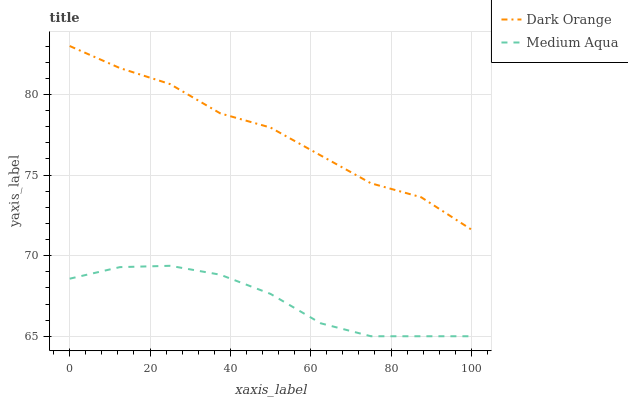Does Medium Aqua have the minimum area under the curve?
Answer yes or no. Yes. Does Dark Orange have the maximum area under the curve?
Answer yes or no. Yes. Does Medium Aqua have the maximum area under the curve?
Answer yes or no. No. Is Medium Aqua the smoothest?
Answer yes or no. Yes. Is Dark Orange the roughest?
Answer yes or no. Yes. Is Medium Aqua the roughest?
Answer yes or no. No. Does Medium Aqua have the lowest value?
Answer yes or no. Yes. Does Dark Orange have the highest value?
Answer yes or no. Yes. Does Medium Aqua have the highest value?
Answer yes or no. No. Is Medium Aqua less than Dark Orange?
Answer yes or no. Yes. Is Dark Orange greater than Medium Aqua?
Answer yes or no. Yes. Does Medium Aqua intersect Dark Orange?
Answer yes or no. No. 